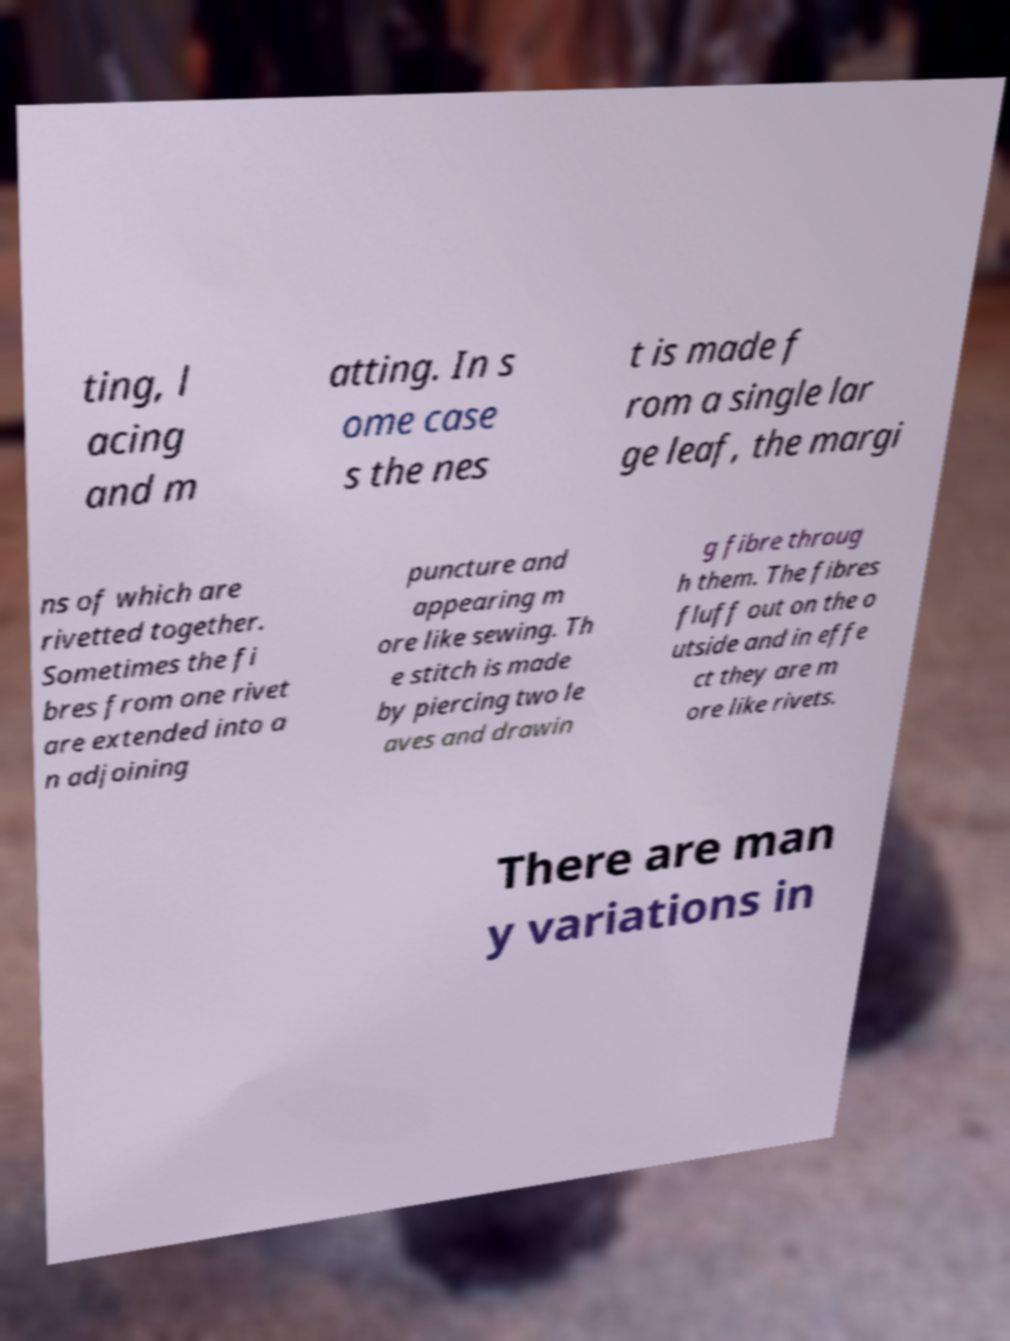For documentation purposes, I need the text within this image transcribed. Could you provide that? ting, l acing and m atting. In s ome case s the nes t is made f rom a single lar ge leaf, the margi ns of which are rivetted together. Sometimes the fi bres from one rivet are extended into a n adjoining puncture and appearing m ore like sewing. Th e stitch is made by piercing two le aves and drawin g fibre throug h them. The fibres fluff out on the o utside and in effe ct they are m ore like rivets. There are man y variations in 